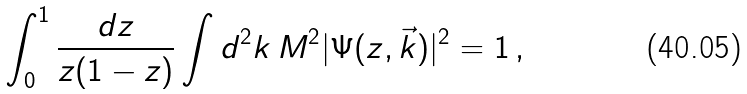Convert formula to latex. <formula><loc_0><loc_0><loc_500><loc_500>\int _ { 0 } ^ { 1 } \frac { d z } { z ( 1 - z ) } \int d ^ { 2 } k \, M ^ { 2 } | \Psi ( z , \vec { k } ) | ^ { 2 } = 1 \, ,</formula> 